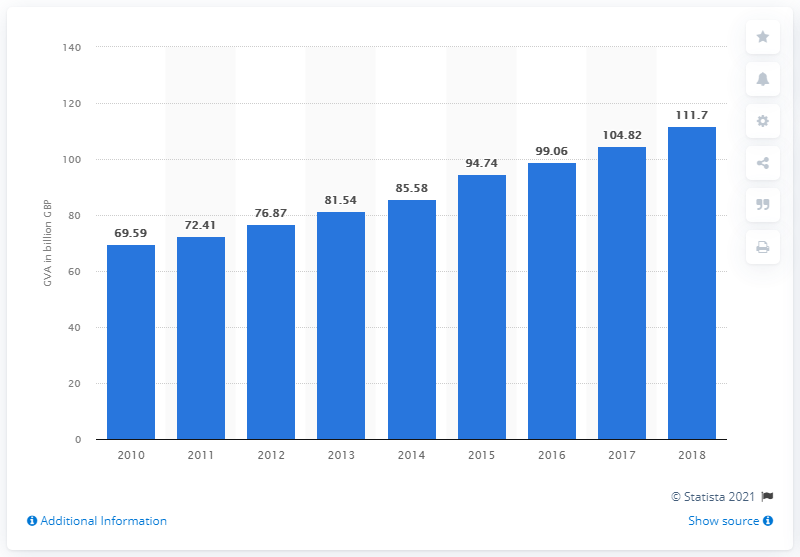Draw attention to some important aspects in this diagram. In 2018, the gross value of the creative industries in the UK was 111.7 billion pounds. 